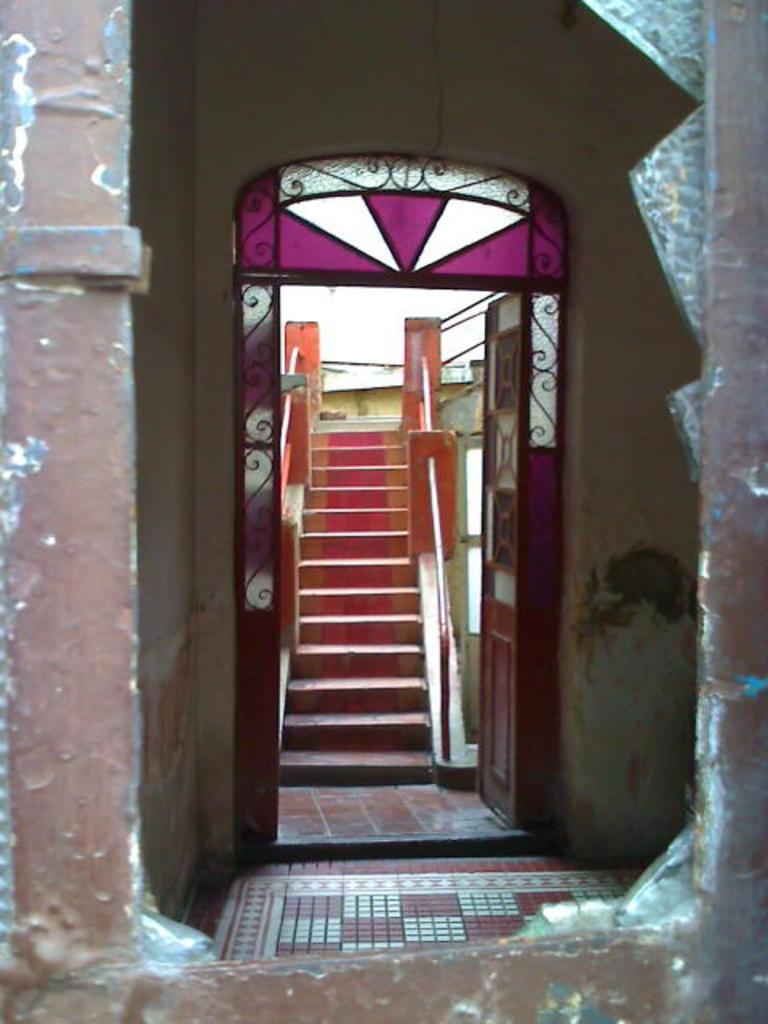What is the main feature in the foreground of the image? There is a broken window in the foreground of the image. What architectural elements can be seen in the background of the image? There are stairs and a door in the background of the image. How many girls are playing on the level in the image? There are no girls or levels present in the image; it features a broken window and background architectural elements. 